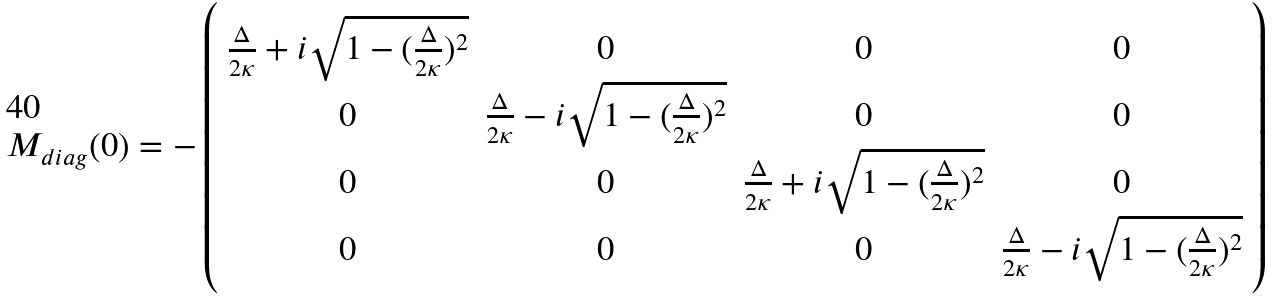<formula> <loc_0><loc_0><loc_500><loc_500>M _ { d i a g } ( 0 ) = - \left ( \begin{array} { c c c c } \frac { \Delta } { 2 \kappa } + i \sqrt { 1 - ( \frac { \Delta } { 2 \kappa } ) ^ { 2 } } & 0 & 0 & 0 \\ 0 & \frac { \Delta } { 2 \kappa } - i \sqrt { 1 - ( \frac { \Delta } { 2 \kappa } ) ^ { 2 } } & 0 & 0 \\ 0 & 0 & \frac { \Delta } { 2 \kappa } + i \sqrt { 1 - ( \frac { \Delta } { 2 \kappa } ) ^ { 2 } } & 0 \\ 0 & 0 & 0 & \frac { \Delta } { 2 \kappa } - i \sqrt { 1 - ( \frac { \Delta } { 2 \kappa } ) ^ { 2 } } \end{array} \right )</formula> 